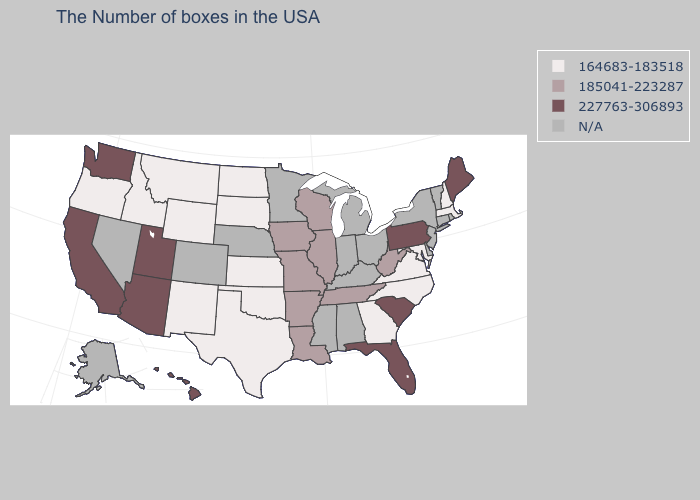Name the states that have a value in the range 164683-183518?
Write a very short answer. Massachusetts, New Hampshire, Maryland, Virginia, North Carolina, Georgia, Kansas, Oklahoma, Texas, South Dakota, North Dakota, Wyoming, New Mexico, Montana, Idaho, Oregon. Which states have the highest value in the USA?
Be succinct. Maine, Pennsylvania, South Carolina, Florida, Utah, Arizona, California, Washington, Hawaii. What is the value of Indiana?
Answer briefly. N/A. What is the value of Iowa?
Short answer required. 185041-223287. What is the highest value in states that border Mississippi?
Keep it brief. 185041-223287. What is the highest value in the Northeast ?
Be succinct. 227763-306893. What is the value of Iowa?
Concise answer only. 185041-223287. What is the lowest value in states that border Kansas?
Answer briefly. 164683-183518. Name the states that have a value in the range 164683-183518?
Give a very brief answer. Massachusetts, New Hampshire, Maryland, Virginia, North Carolina, Georgia, Kansas, Oklahoma, Texas, South Dakota, North Dakota, Wyoming, New Mexico, Montana, Idaho, Oregon. What is the lowest value in the USA?
Keep it brief. 164683-183518. Name the states that have a value in the range N/A?
Give a very brief answer. Rhode Island, Vermont, Connecticut, New York, New Jersey, Delaware, Ohio, Michigan, Kentucky, Indiana, Alabama, Mississippi, Minnesota, Nebraska, Colorado, Nevada, Alaska. What is the value of Delaware?
Concise answer only. N/A. Name the states that have a value in the range 227763-306893?
Keep it brief. Maine, Pennsylvania, South Carolina, Florida, Utah, Arizona, California, Washington, Hawaii. Name the states that have a value in the range 164683-183518?
Short answer required. Massachusetts, New Hampshire, Maryland, Virginia, North Carolina, Georgia, Kansas, Oklahoma, Texas, South Dakota, North Dakota, Wyoming, New Mexico, Montana, Idaho, Oregon. 